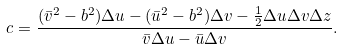<formula> <loc_0><loc_0><loc_500><loc_500>c = \frac { ( \bar { v } ^ { 2 } - b ^ { 2 } ) \Delta u - ( \bar { u } ^ { 2 } - b ^ { 2 } ) \Delta v - \frac { 1 } { 2 } \Delta u \Delta v \Delta z } { \bar { v } \Delta u - \bar { u } \Delta v } .</formula> 